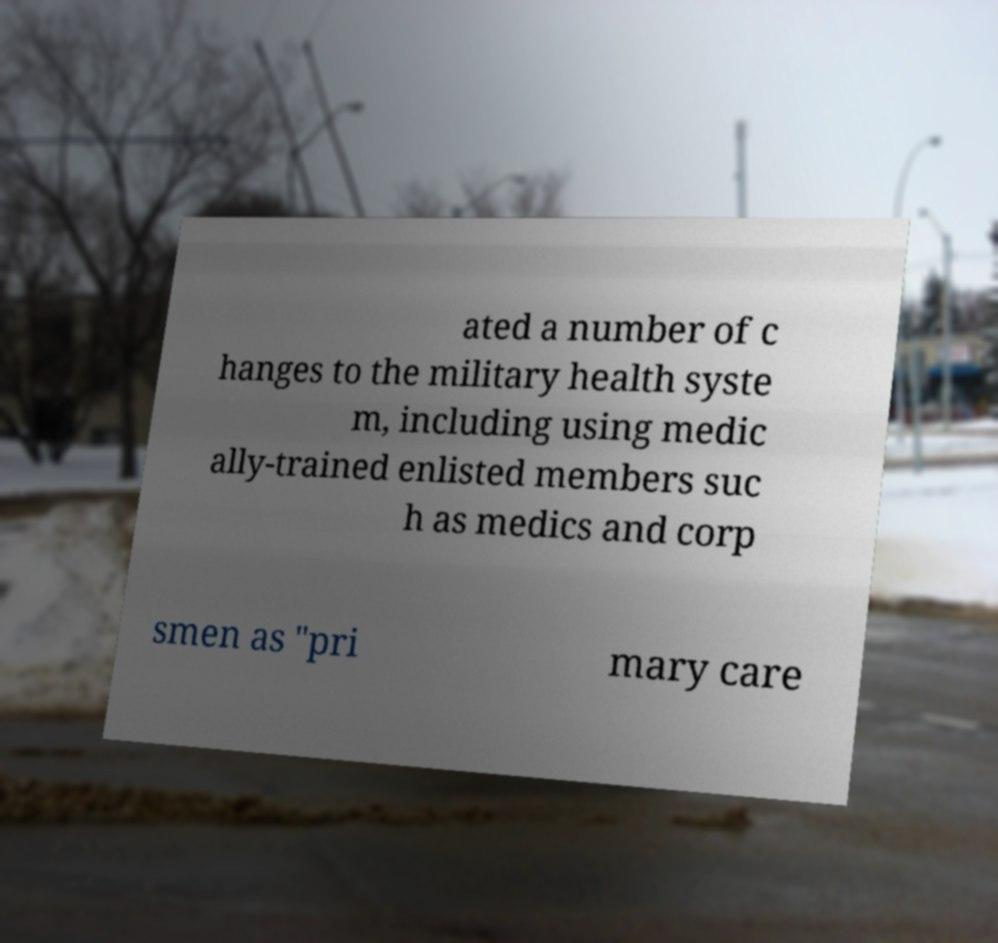Could you extract and type out the text from this image? ated a number of c hanges to the military health syste m, including using medic ally-trained enlisted members suc h as medics and corp smen as "pri mary care 